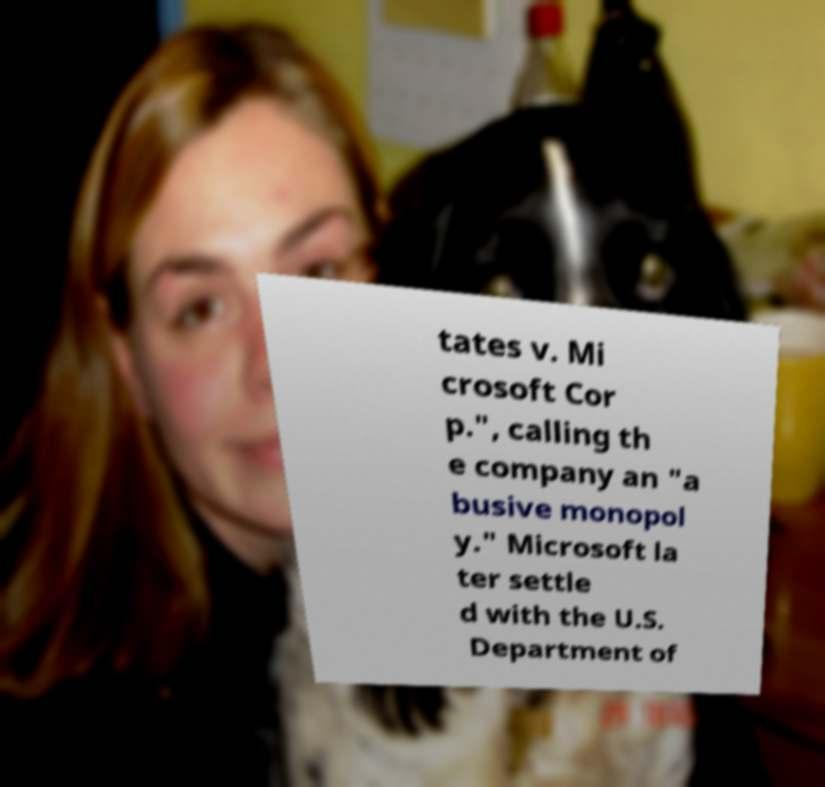What messages or text are displayed in this image? I need them in a readable, typed format. tates v. Mi crosoft Cor p.", calling th e company an "a busive monopol y." Microsoft la ter settle d with the U.S. Department of 